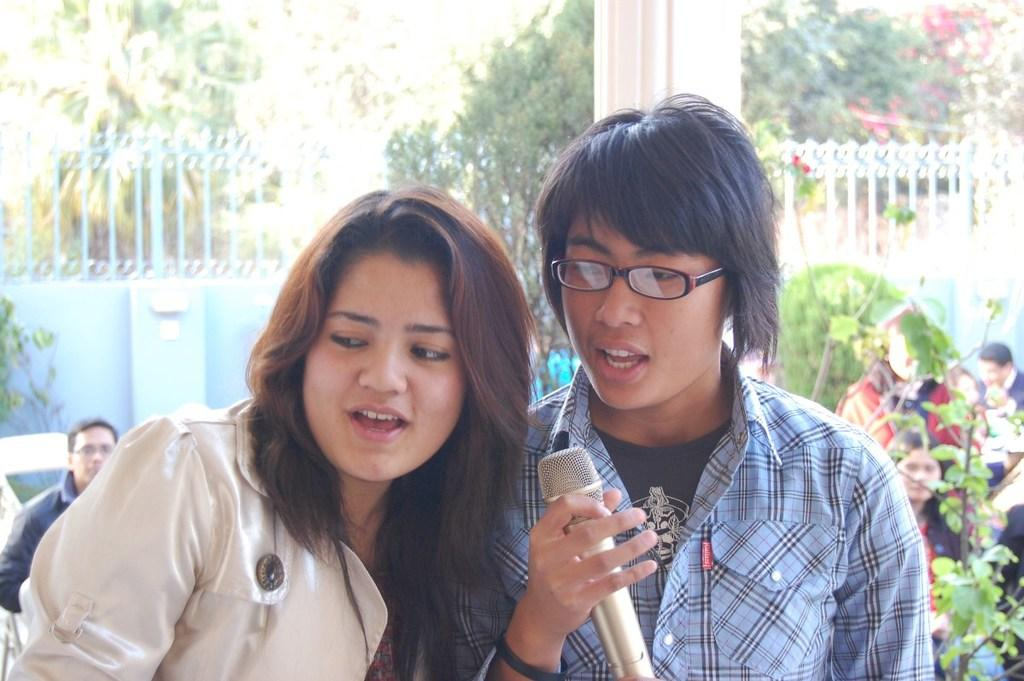How many persons are in the center of the image? There are two persons standing in the center of the image. What are the two persons holding in the image? The two persons are holding microphones. What is the facial expression of the two persons in the image? The two persons are smiling. What can be seen in the background of the image? There are trees, a pillar, and a wall in the background of the image. Are there any other people visible in the image? Yes, there are additional persons standing in the background of the image. What type of border is visible around the faces of the two persons in the image? There is no border visible around the faces of the two persons in the image. What need does the person on the left have in the image? It is not possible to determine the needs of the person on the left from the image alone. 